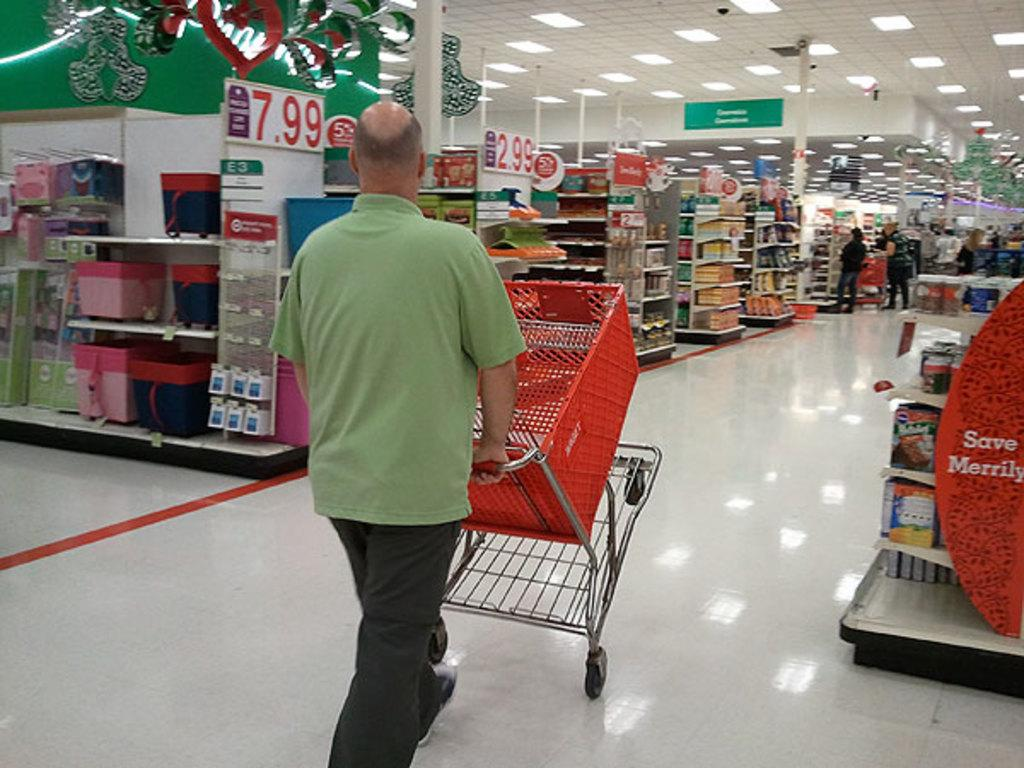<image>
Present a compact description of the photo's key features. A man pushing a trolley through a store on which the numbers 7.99 can be seen. 